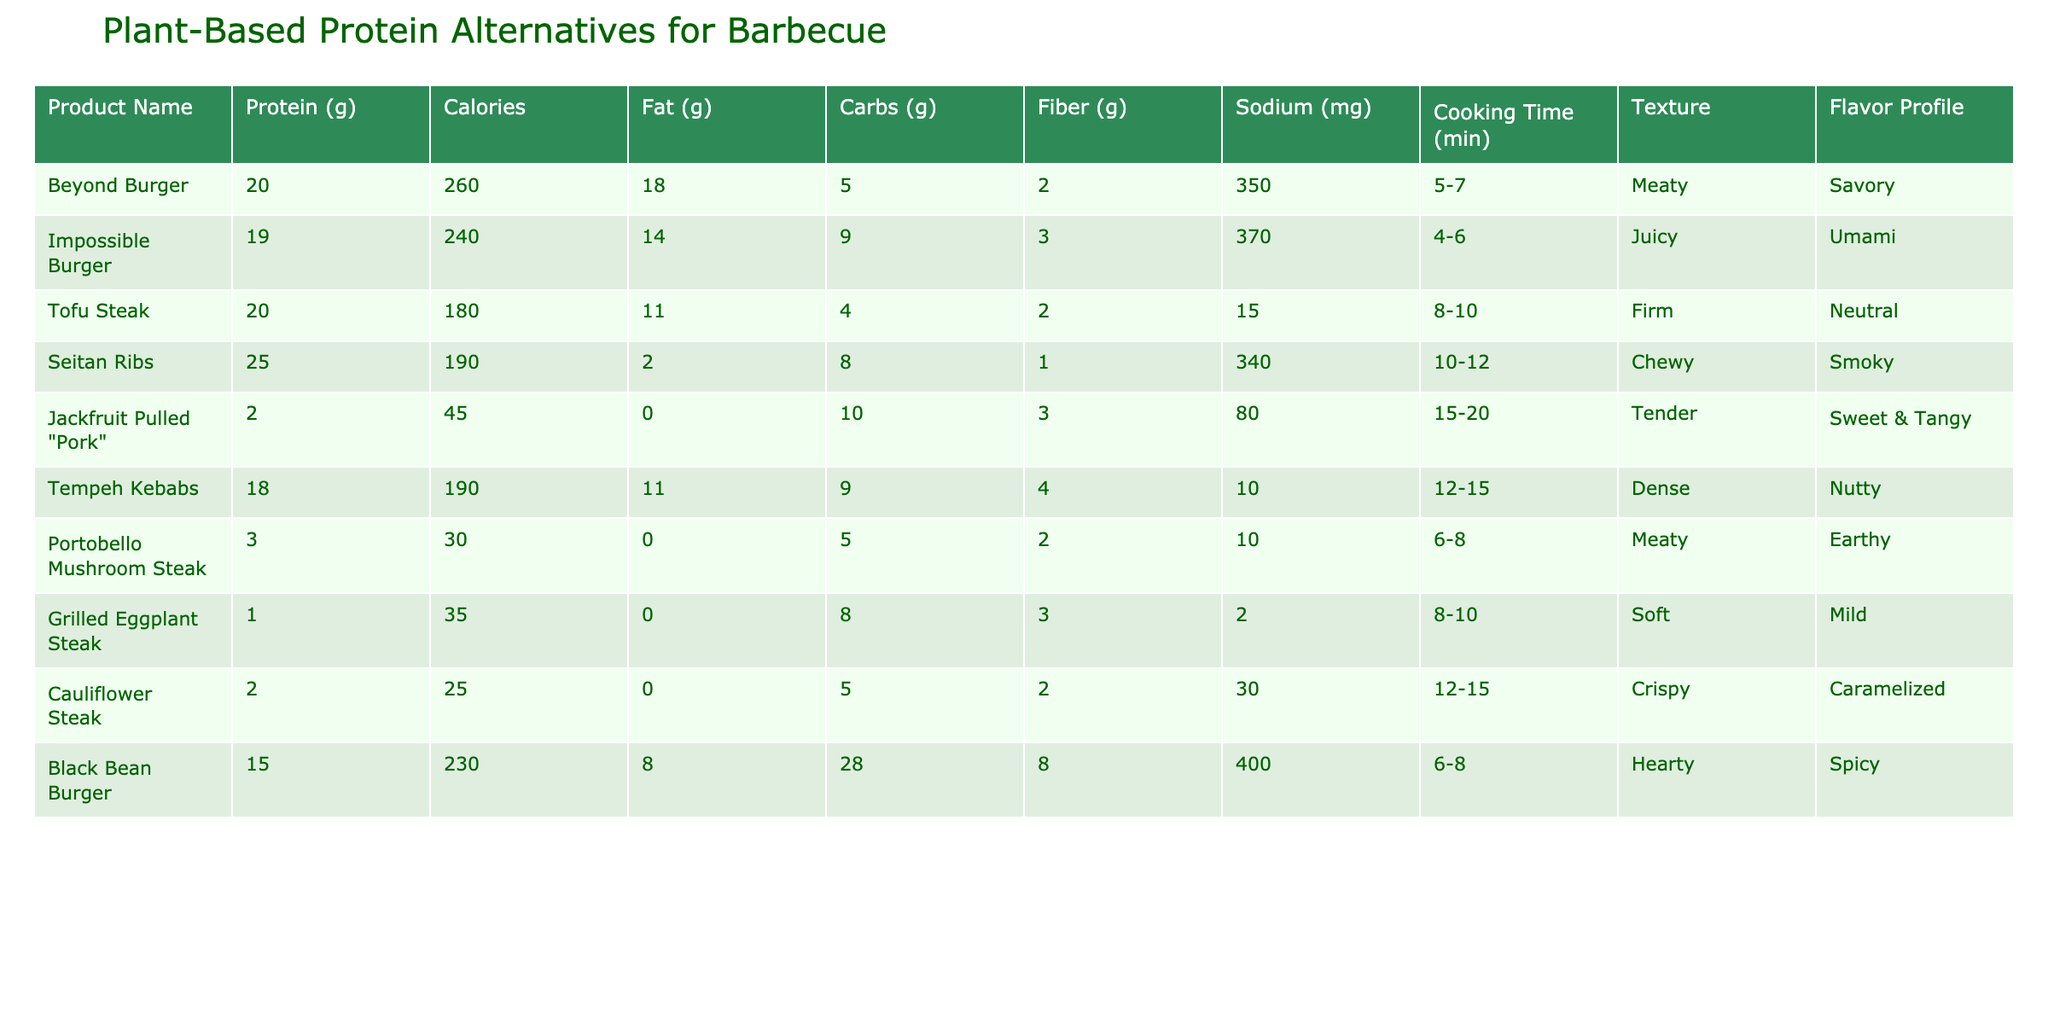What is the protein content of the Seitan Ribs? The table specifies that the Seitan Ribs have a protein content of 25 grams per serving, as listed under the Protein column associated with the Seitan Ribs row.
Answer: 25 grams Which product has the least calories? The product with the least calories is the Cauliflower Steak, which has 25 calories listed in the Calories column.
Answer: 25 calories How much fiber is in the Black Bean Burger compared to the Tofu Steak? The Black Bean Burger has 8 grams of fiber, while the Tofu Steak has 2 grams. The difference is calculated as 8 - 2 = 6 grams more fiber in the Black Bean Burger.
Answer: 6 grams Is the Impossible Burger higher in fat than the Jackfruit Pulled "Pork"? The Impossible Burger contains 14 grams of fat, while the Jackfruit Pulled "Pork" has 0 grams of fat. Therefore, it is true that the Impossible Burger is higher in fat than the Jackfruit Pulled "Pork".
Answer: Yes What is the average protein content of the plant-based alternatives listed? To calculate the average protein content, sum the protein values: 20 (Beyond Burger) + 19 (Impossible Burger) + 20 (Tofu Steak) + 25 (Seitan Ribs) + 2 (Jackfruit Pulled "Pork") + 18 (Tempeh Kebabs) + 3 (Portobello Mushroom Steak) + 1 (Grilled Eggplant Steak) + 2 (Cauliflower Steak) + 15 (Black Bean Burger) = 105 grams. Then, divide by the number of products (10), giving an average of 105 / 10 = 10.5 grams of protein per product.
Answer: 10.5 grams Which product has the highest amount of sodium? The Black Bean Burger has the highest sodium content, measured at 400 mg in the Sodium column.
Answer: 400 mg 